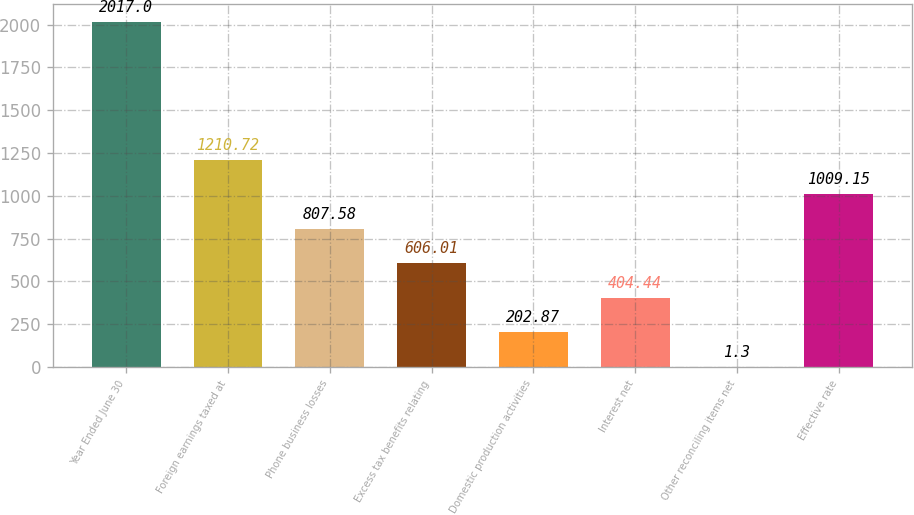<chart> <loc_0><loc_0><loc_500><loc_500><bar_chart><fcel>Year Ended June 30<fcel>Foreign earnings taxed at<fcel>Phone business losses<fcel>Excess tax benefits relating<fcel>Domestic production activities<fcel>Interest net<fcel>Other reconciling items net<fcel>Effective rate<nl><fcel>2017<fcel>1210.72<fcel>807.58<fcel>606.01<fcel>202.87<fcel>404.44<fcel>1.3<fcel>1009.15<nl></chart> 